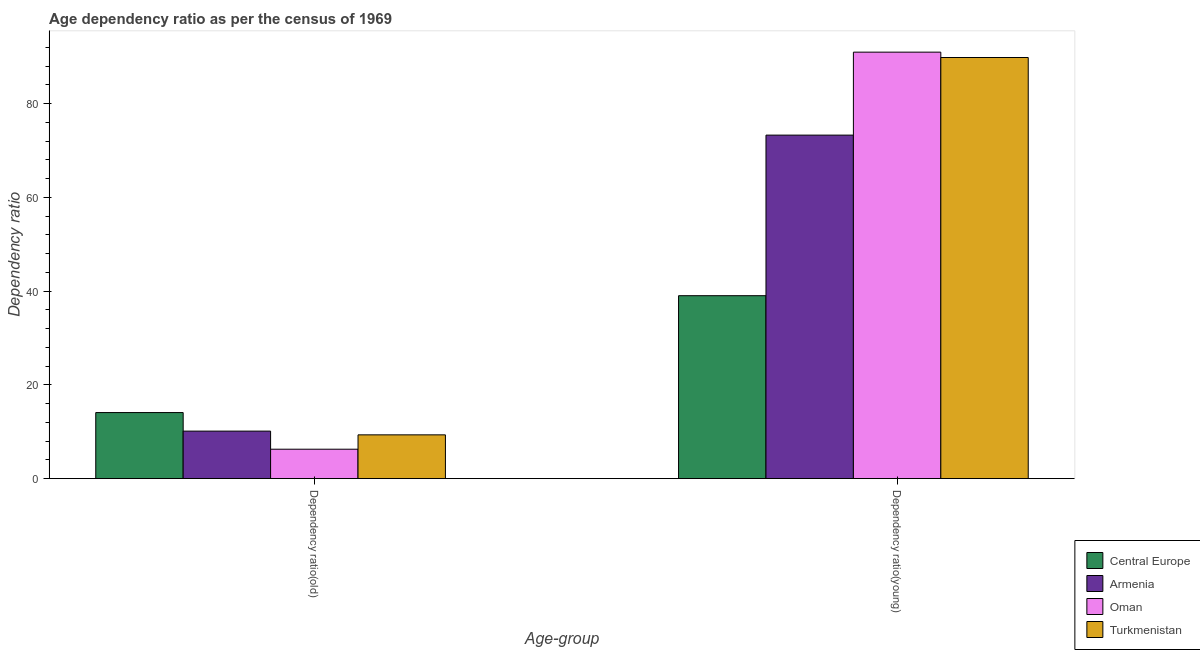How many bars are there on the 2nd tick from the left?
Provide a succinct answer. 4. What is the label of the 1st group of bars from the left?
Keep it short and to the point. Dependency ratio(old). What is the age dependency ratio(old) in Central Europe?
Your response must be concise. 14.09. Across all countries, what is the maximum age dependency ratio(old)?
Ensure brevity in your answer.  14.09. Across all countries, what is the minimum age dependency ratio(old)?
Provide a short and direct response. 6.27. In which country was the age dependency ratio(young) maximum?
Offer a very short reply. Oman. In which country was the age dependency ratio(young) minimum?
Ensure brevity in your answer.  Central Europe. What is the total age dependency ratio(young) in the graph?
Your answer should be compact. 293.07. What is the difference between the age dependency ratio(young) in Central Europe and that in Turkmenistan?
Your answer should be compact. -50.8. What is the difference between the age dependency ratio(young) in Turkmenistan and the age dependency ratio(old) in Oman?
Offer a terse response. 83.55. What is the average age dependency ratio(young) per country?
Make the answer very short. 73.27. What is the difference between the age dependency ratio(young) and age dependency ratio(old) in Armenia?
Your answer should be compact. 63.14. In how many countries, is the age dependency ratio(young) greater than 80 ?
Give a very brief answer. 2. What is the ratio of the age dependency ratio(young) in Oman to that in Turkmenistan?
Your response must be concise. 1.01. Is the age dependency ratio(young) in Central Europe less than that in Turkmenistan?
Offer a very short reply. Yes. What does the 3rd bar from the left in Dependency ratio(young) represents?
Provide a succinct answer. Oman. What does the 2nd bar from the right in Dependency ratio(old) represents?
Offer a very short reply. Oman. Are all the bars in the graph horizontal?
Provide a succinct answer. No. How many countries are there in the graph?
Your answer should be compact. 4. Does the graph contain any zero values?
Your answer should be compact. No. How many legend labels are there?
Your answer should be very brief. 4. How are the legend labels stacked?
Provide a short and direct response. Vertical. What is the title of the graph?
Your response must be concise. Age dependency ratio as per the census of 1969. Does "Niger" appear as one of the legend labels in the graph?
Offer a very short reply. No. What is the label or title of the X-axis?
Provide a short and direct response. Age-group. What is the label or title of the Y-axis?
Ensure brevity in your answer.  Dependency ratio. What is the Dependency ratio in Central Europe in Dependency ratio(old)?
Offer a very short reply. 14.09. What is the Dependency ratio in Armenia in Dependency ratio(old)?
Your answer should be compact. 10.13. What is the Dependency ratio in Oman in Dependency ratio(old)?
Keep it short and to the point. 6.27. What is the Dependency ratio in Turkmenistan in Dependency ratio(old)?
Ensure brevity in your answer.  9.34. What is the Dependency ratio of Central Europe in Dependency ratio(young)?
Your answer should be compact. 39.02. What is the Dependency ratio in Armenia in Dependency ratio(young)?
Give a very brief answer. 73.27. What is the Dependency ratio in Oman in Dependency ratio(young)?
Your answer should be compact. 90.96. What is the Dependency ratio in Turkmenistan in Dependency ratio(young)?
Provide a short and direct response. 89.82. Across all Age-group, what is the maximum Dependency ratio in Central Europe?
Provide a succinct answer. 39.02. Across all Age-group, what is the maximum Dependency ratio of Armenia?
Make the answer very short. 73.27. Across all Age-group, what is the maximum Dependency ratio of Oman?
Keep it short and to the point. 90.96. Across all Age-group, what is the maximum Dependency ratio of Turkmenistan?
Ensure brevity in your answer.  89.82. Across all Age-group, what is the minimum Dependency ratio in Central Europe?
Your answer should be compact. 14.09. Across all Age-group, what is the minimum Dependency ratio of Armenia?
Keep it short and to the point. 10.13. Across all Age-group, what is the minimum Dependency ratio in Oman?
Your answer should be very brief. 6.27. Across all Age-group, what is the minimum Dependency ratio of Turkmenistan?
Your answer should be very brief. 9.34. What is the total Dependency ratio in Central Europe in the graph?
Provide a short and direct response. 53.1. What is the total Dependency ratio in Armenia in the graph?
Your response must be concise. 83.4. What is the total Dependency ratio of Oman in the graph?
Offer a terse response. 97.24. What is the total Dependency ratio in Turkmenistan in the graph?
Provide a short and direct response. 99.16. What is the difference between the Dependency ratio of Central Europe in Dependency ratio(old) and that in Dependency ratio(young)?
Keep it short and to the point. -24.93. What is the difference between the Dependency ratio in Armenia in Dependency ratio(old) and that in Dependency ratio(young)?
Make the answer very short. -63.14. What is the difference between the Dependency ratio of Oman in Dependency ratio(old) and that in Dependency ratio(young)?
Provide a short and direct response. -84.69. What is the difference between the Dependency ratio in Turkmenistan in Dependency ratio(old) and that in Dependency ratio(young)?
Offer a terse response. -80.49. What is the difference between the Dependency ratio of Central Europe in Dependency ratio(old) and the Dependency ratio of Armenia in Dependency ratio(young)?
Make the answer very short. -59.18. What is the difference between the Dependency ratio in Central Europe in Dependency ratio(old) and the Dependency ratio in Oman in Dependency ratio(young)?
Your answer should be compact. -76.88. What is the difference between the Dependency ratio of Central Europe in Dependency ratio(old) and the Dependency ratio of Turkmenistan in Dependency ratio(young)?
Your answer should be compact. -75.73. What is the difference between the Dependency ratio in Armenia in Dependency ratio(old) and the Dependency ratio in Oman in Dependency ratio(young)?
Make the answer very short. -80.84. What is the difference between the Dependency ratio of Armenia in Dependency ratio(old) and the Dependency ratio of Turkmenistan in Dependency ratio(young)?
Your answer should be compact. -79.69. What is the difference between the Dependency ratio of Oman in Dependency ratio(old) and the Dependency ratio of Turkmenistan in Dependency ratio(young)?
Your answer should be compact. -83.55. What is the average Dependency ratio of Central Europe per Age-group?
Your answer should be very brief. 26.55. What is the average Dependency ratio in Armenia per Age-group?
Provide a succinct answer. 41.7. What is the average Dependency ratio in Oman per Age-group?
Your answer should be very brief. 48.62. What is the average Dependency ratio of Turkmenistan per Age-group?
Make the answer very short. 49.58. What is the difference between the Dependency ratio of Central Europe and Dependency ratio of Armenia in Dependency ratio(old)?
Provide a short and direct response. 3.96. What is the difference between the Dependency ratio of Central Europe and Dependency ratio of Oman in Dependency ratio(old)?
Keep it short and to the point. 7.81. What is the difference between the Dependency ratio in Central Europe and Dependency ratio in Turkmenistan in Dependency ratio(old)?
Provide a succinct answer. 4.75. What is the difference between the Dependency ratio of Armenia and Dependency ratio of Oman in Dependency ratio(old)?
Your answer should be very brief. 3.86. What is the difference between the Dependency ratio of Armenia and Dependency ratio of Turkmenistan in Dependency ratio(old)?
Give a very brief answer. 0.79. What is the difference between the Dependency ratio of Oman and Dependency ratio of Turkmenistan in Dependency ratio(old)?
Your response must be concise. -3.06. What is the difference between the Dependency ratio of Central Europe and Dependency ratio of Armenia in Dependency ratio(young)?
Provide a short and direct response. -34.25. What is the difference between the Dependency ratio of Central Europe and Dependency ratio of Oman in Dependency ratio(young)?
Ensure brevity in your answer.  -51.95. What is the difference between the Dependency ratio of Central Europe and Dependency ratio of Turkmenistan in Dependency ratio(young)?
Make the answer very short. -50.8. What is the difference between the Dependency ratio of Armenia and Dependency ratio of Oman in Dependency ratio(young)?
Provide a succinct answer. -17.7. What is the difference between the Dependency ratio in Armenia and Dependency ratio in Turkmenistan in Dependency ratio(young)?
Ensure brevity in your answer.  -16.55. What is the difference between the Dependency ratio of Oman and Dependency ratio of Turkmenistan in Dependency ratio(young)?
Give a very brief answer. 1.14. What is the ratio of the Dependency ratio in Central Europe in Dependency ratio(old) to that in Dependency ratio(young)?
Offer a very short reply. 0.36. What is the ratio of the Dependency ratio in Armenia in Dependency ratio(old) to that in Dependency ratio(young)?
Your answer should be compact. 0.14. What is the ratio of the Dependency ratio of Oman in Dependency ratio(old) to that in Dependency ratio(young)?
Make the answer very short. 0.07. What is the ratio of the Dependency ratio in Turkmenistan in Dependency ratio(old) to that in Dependency ratio(young)?
Your answer should be very brief. 0.1. What is the difference between the highest and the second highest Dependency ratio of Central Europe?
Give a very brief answer. 24.93. What is the difference between the highest and the second highest Dependency ratio of Armenia?
Make the answer very short. 63.14. What is the difference between the highest and the second highest Dependency ratio of Oman?
Give a very brief answer. 84.69. What is the difference between the highest and the second highest Dependency ratio in Turkmenistan?
Provide a short and direct response. 80.49. What is the difference between the highest and the lowest Dependency ratio in Central Europe?
Give a very brief answer. 24.93. What is the difference between the highest and the lowest Dependency ratio of Armenia?
Your answer should be very brief. 63.14. What is the difference between the highest and the lowest Dependency ratio in Oman?
Ensure brevity in your answer.  84.69. What is the difference between the highest and the lowest Dependency ratio of Turkmenistan?
Provide a succinct answer. 80.49. 